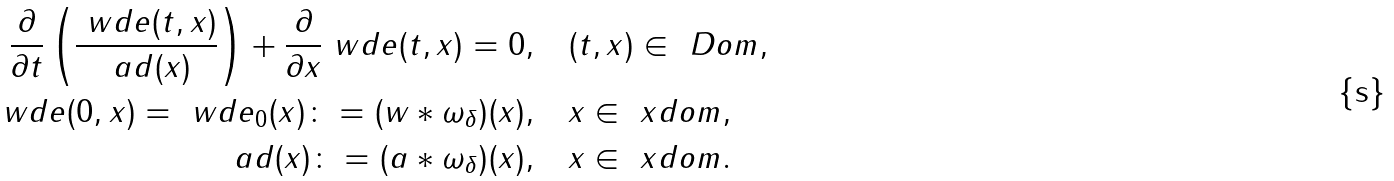<formula> <loc_0><loc_0><loc_500><loc_500>\frac { \partial } { \partial t } \left ( \frac { \ w d e ( t , x ) } { \ a d ( x ) } \right ) + \frac { \partial } { \partial x } \ w d e ( t , x ) = 0 , & \quad ( t , x ) \in \ D o m , \\ \ w d e ( 0 , x ) = \ w d e _ { 0 } ( x ) \colon = ( w \ast \omega _ { \delta } ) ( x ) , & \quad x \in \ x d o m , \\ \ a d ( x ) \colon = ( a \ast \omega _ { \delta } ) ( x ) , & \quad x \in \ x d o m .</formula> 